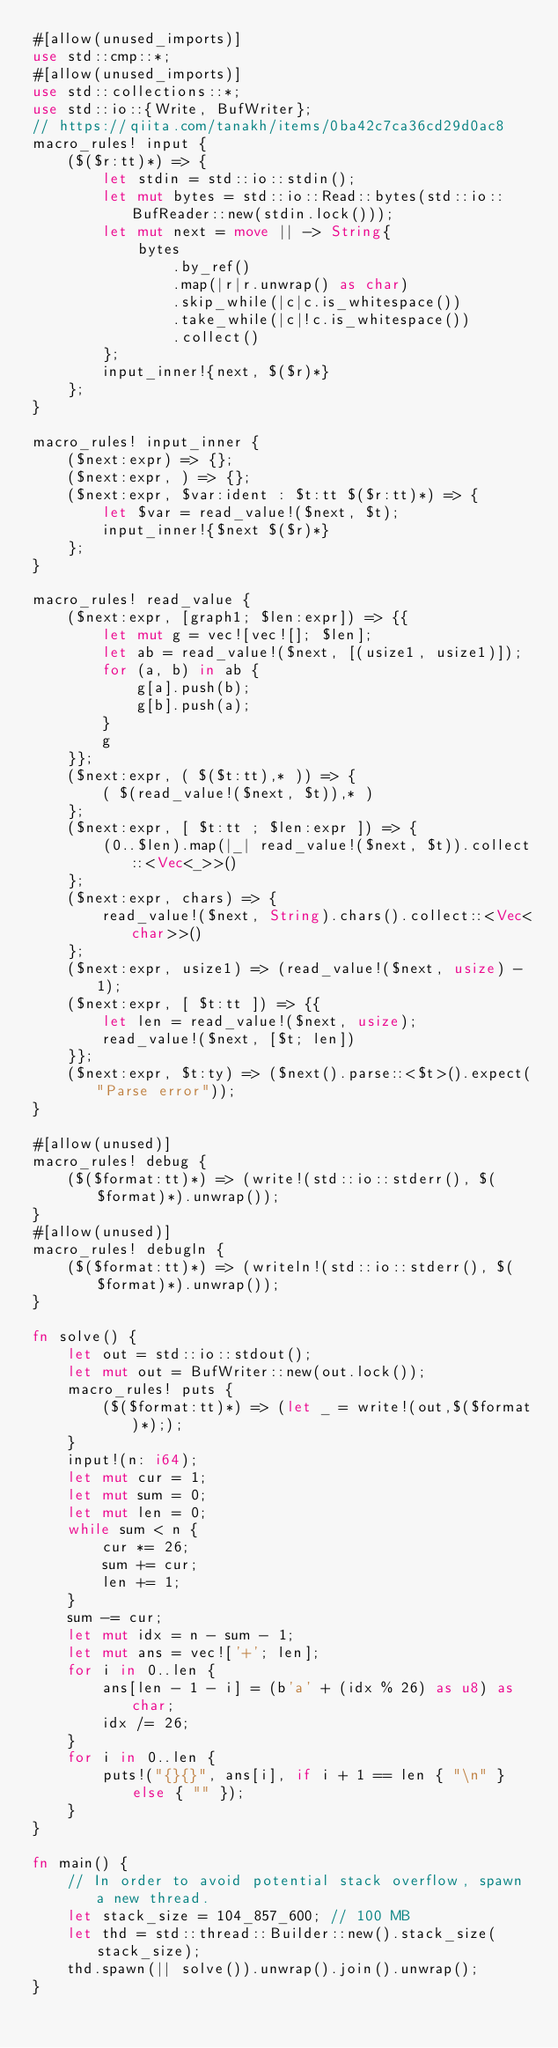Convert code to text. <code><loc_0><loc_0><loc_500><loc_500><_Rust_>#[allow(unused_imports)]
use std::cmp::*;
#[allow(unused_imports)]
use std::collections::*;
use std::io::{Write, BufWriter};
// https://qiita.com/tanakh/items/0ba42c7ca36cd29d0ac8
macro_rules! input {
    ($($r:tt)*) => {
        let stdin = std::io::stdin();
        let mut bytes = std::io::Read::bytes(std::io::BufReader::new(stdin.lock()));
        let mut next = move || -> String{
            bytes
                .by_ref()
                .map(|r|r.unwrap() as char)
                .skip_while(|c|c.is_whitespace())
                .take_while(|c|!c.is_whitespace())
                .collect()
        };
        input_inner!{next, $($r)*}
    };
}

macro_rules! input_inner {
    ($next:expr) => {};
    ($next:expr, ) => {};
    ($next:expr, $var:ident : $t:tt $($r:tt)*) => {
        let $var = read_value!($next, $t);
        input_inner!{$next $($r)*}
    };
}

macro_rules! read_value {
    ($next:expr, [graph1; $len:expr]) => {{
        let mut g = vec![vec![]; $len];
        let ab = read_value!($next, [(usize1, usize1)]);
        for (a, b) in ab {
            g[a].push(b);
            g[b].push(a);
        }
        g
    }};
    ($next:expr, ( $($t:tt),* )) => {
        ( $(read_value!($next, $t)),* )
    };
    ($next:expr, [ $t:tt ; $len:expr ]) => {
        (0..$len).map(|_| read_value!($next, $t)).collect::<Vec<_>>()
    };
    ($next:expr, chars) => {
        read_value!($next, String).chars().collect::<Vec<char>>()
    };
    ($next:expr, usize1) => (read_value!($next, usize) - 1);
    ($next:expr, [ $t:tt ]) => {{
        let len = read_value!($next, usize);
        read_value!($next, [$t; len])
    }};
    ($next:expr, $t:ty) => ($next().parse::<$t>().expect("Parse error"));
}

#[allow(unused)]
macro_rules! debug {
    ($($format:tt)*) => (write!(std::io::stderr(), $($format)*).unwrap());
}
#[allow(unused)]
macro_rules! debugln {
    ($($format:tt)*) => (writeln!(std::io::stderr(), $($format)*).unwrap());
}

fn solve() {
    let out = std::io::stdout();
    let mut out = BufWriter::new(out.lock());
    macro_rules! puts {
        ($($format:tt)*) => (let _ = write!(out,$($format)*););
    }
    input!(n: i64);
    let mut cur = 1;
    let mut sum = 0;
    let mut len = 0;
    while sum < n {
        cur *= 26;
        sum += cur;
        len += 1;
    }
    sum -= cur;
    let mut idx = n - sum - 1;
    let mut ans = vec!['+'; len];
    for i in 0..len {
        ans[len - 1 - i] = (b'a' + (idx % 26) as u8) as char;
        idx /= 26;
    }
    for i in 0..len {
        puts!("{}{}", ans[i], if i + 1 == len { "\n" } else { "" });
    }
}

fn main() {
    // In order to avoid potential stack overflow, spawn a new thread.
    let stack_size = 104_857_600; // 100 MB
    let thd = std::thread::Builder::new().stack_size(stack_size);
    thd.spawn(|| solve()).unwrap().join().unwrap();
}
</code> 